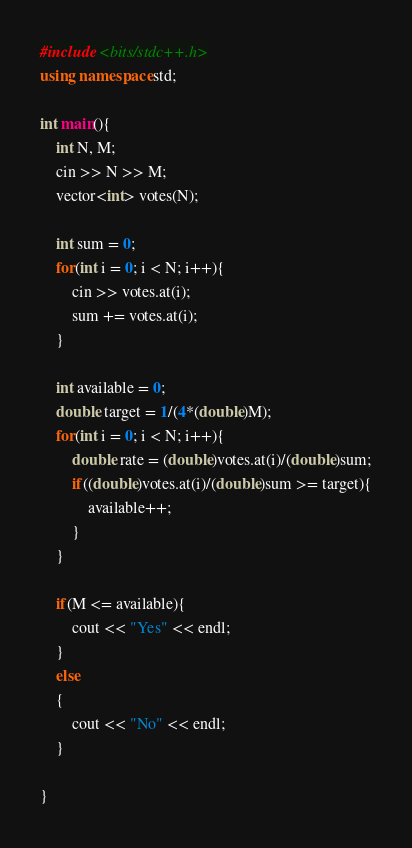Convert code to text. <code><loc_0><loc_0><loc_500><loc_500><_C++_>#include <bits/stdc++.h>
using namespace std;

int main(){
    int N, M;
    cin >> N >> M;
    vector<int> votes(N);

    int sum = 0;
    for(int i = 0; i < N; i++){
        cin >> votes.at(i);
        sum += votes.at(i);
    }

    int available = 0;
    double target = 1/(4*(double)M);
    for(int i = 0; i < N; i++){
        double rate = (double)votes.at(i)/(double)sum;
        if((double)votes.at(i)/(double)sum >= target){
            available++;
        }
    }

    if(M <= available){
        cout << "Yes" << endl;
    }
    else
    {
        cout << "No" << endl;
    }
    
}</code> 